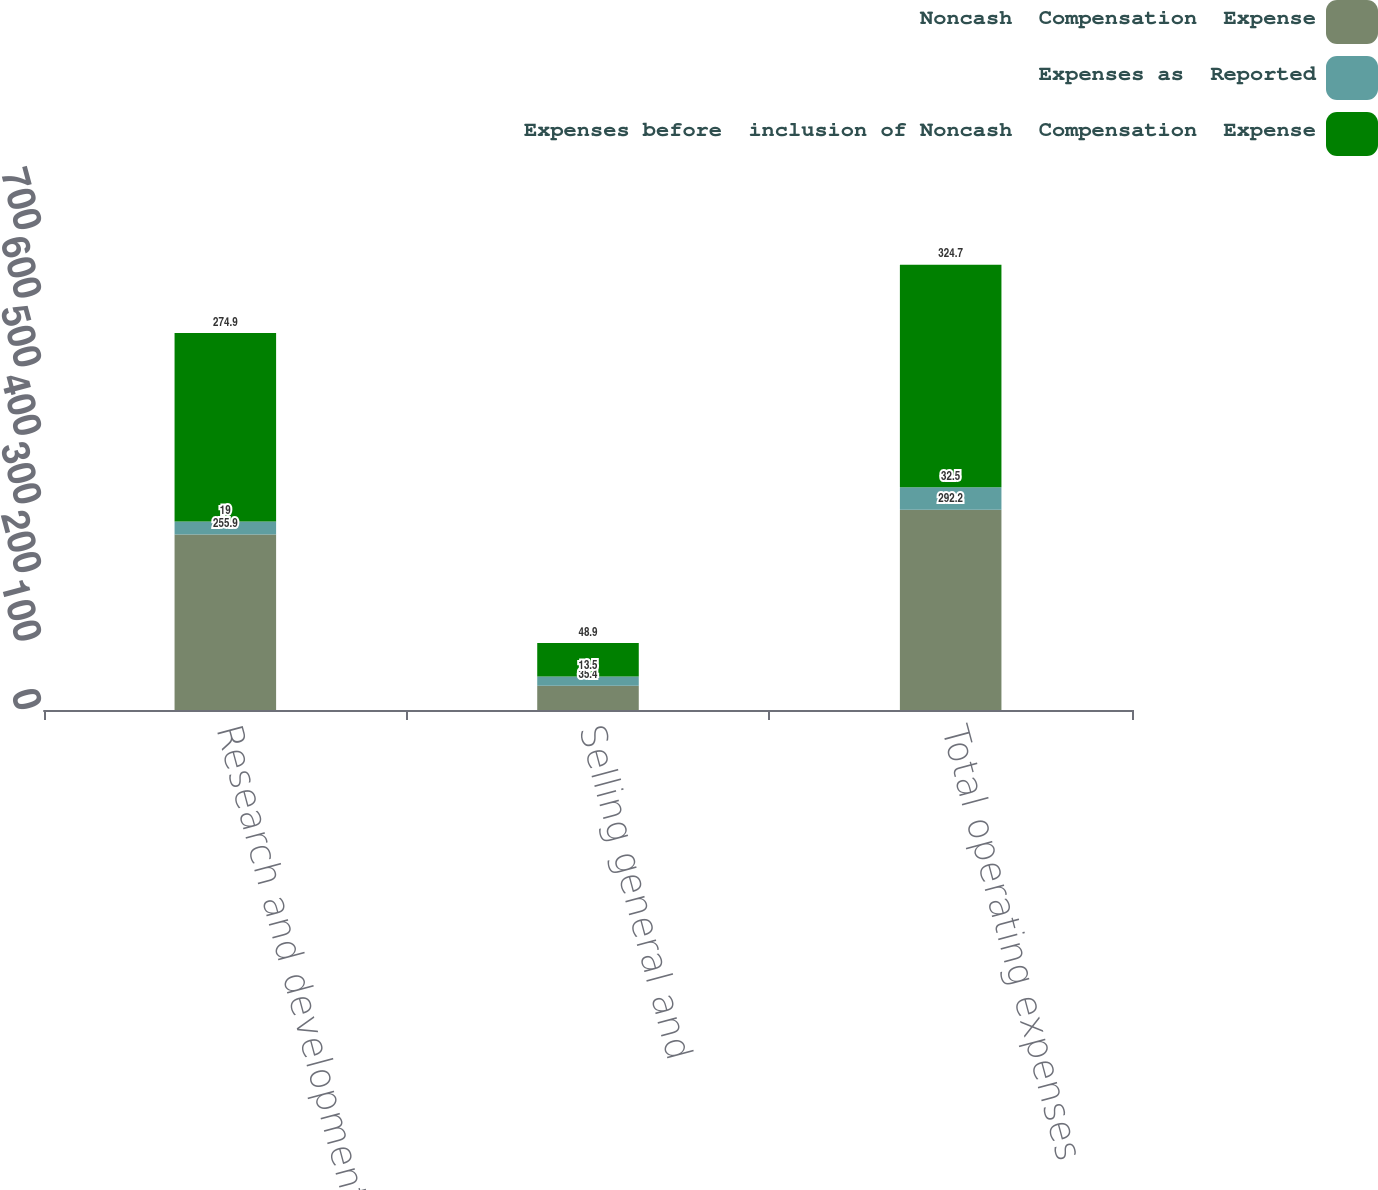<chart> <loc_0><loc_0><loc_500><loc_500><stacked_bar_chart><ecel><fcel>Research and development<fcel>Selling general and<fcel>Total operating expenses<nl><fcel>Noncash  Compensation  Expense<fcel>255.9<fcel>35.4<fcel>292.2<nl><fcel>Expenses as  Reported<fcel>19<fcel>13.5<fcel>32.5<nl><fcel>Expenses before  inclusion of Noncash  Compensation  Expense<fcel>274.9<fcel>48.9<fcel>324.7<nl></chart> 